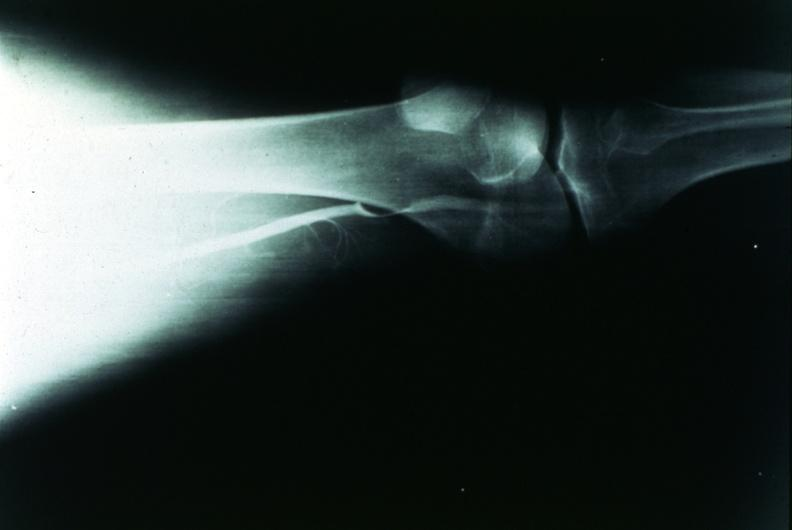s bread-loaf slices into prostate gland present?
Answer the question using a single word or phrase. No 